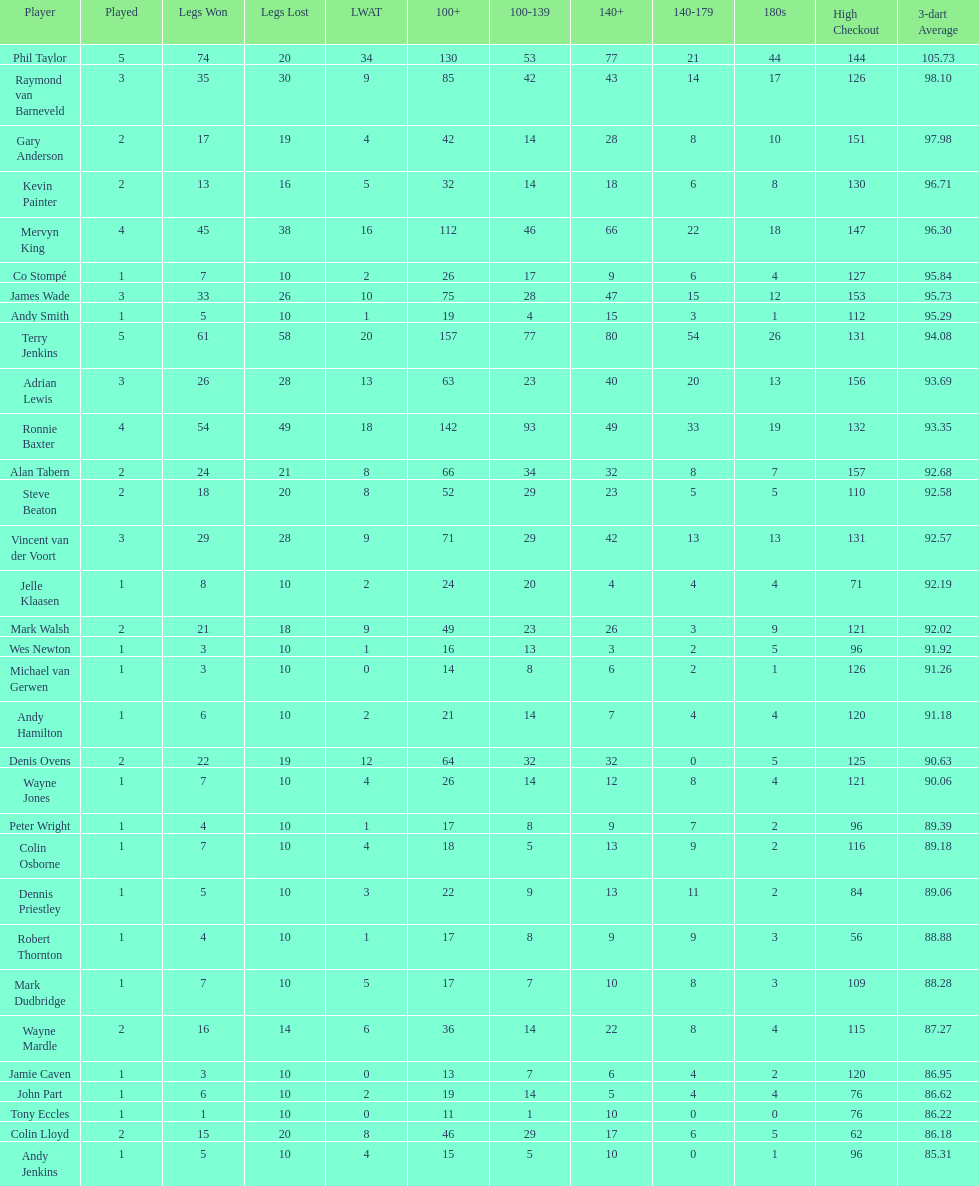List each of the players with a high checkout of 131. Terry Jenkins, Vincent van der Voort. 